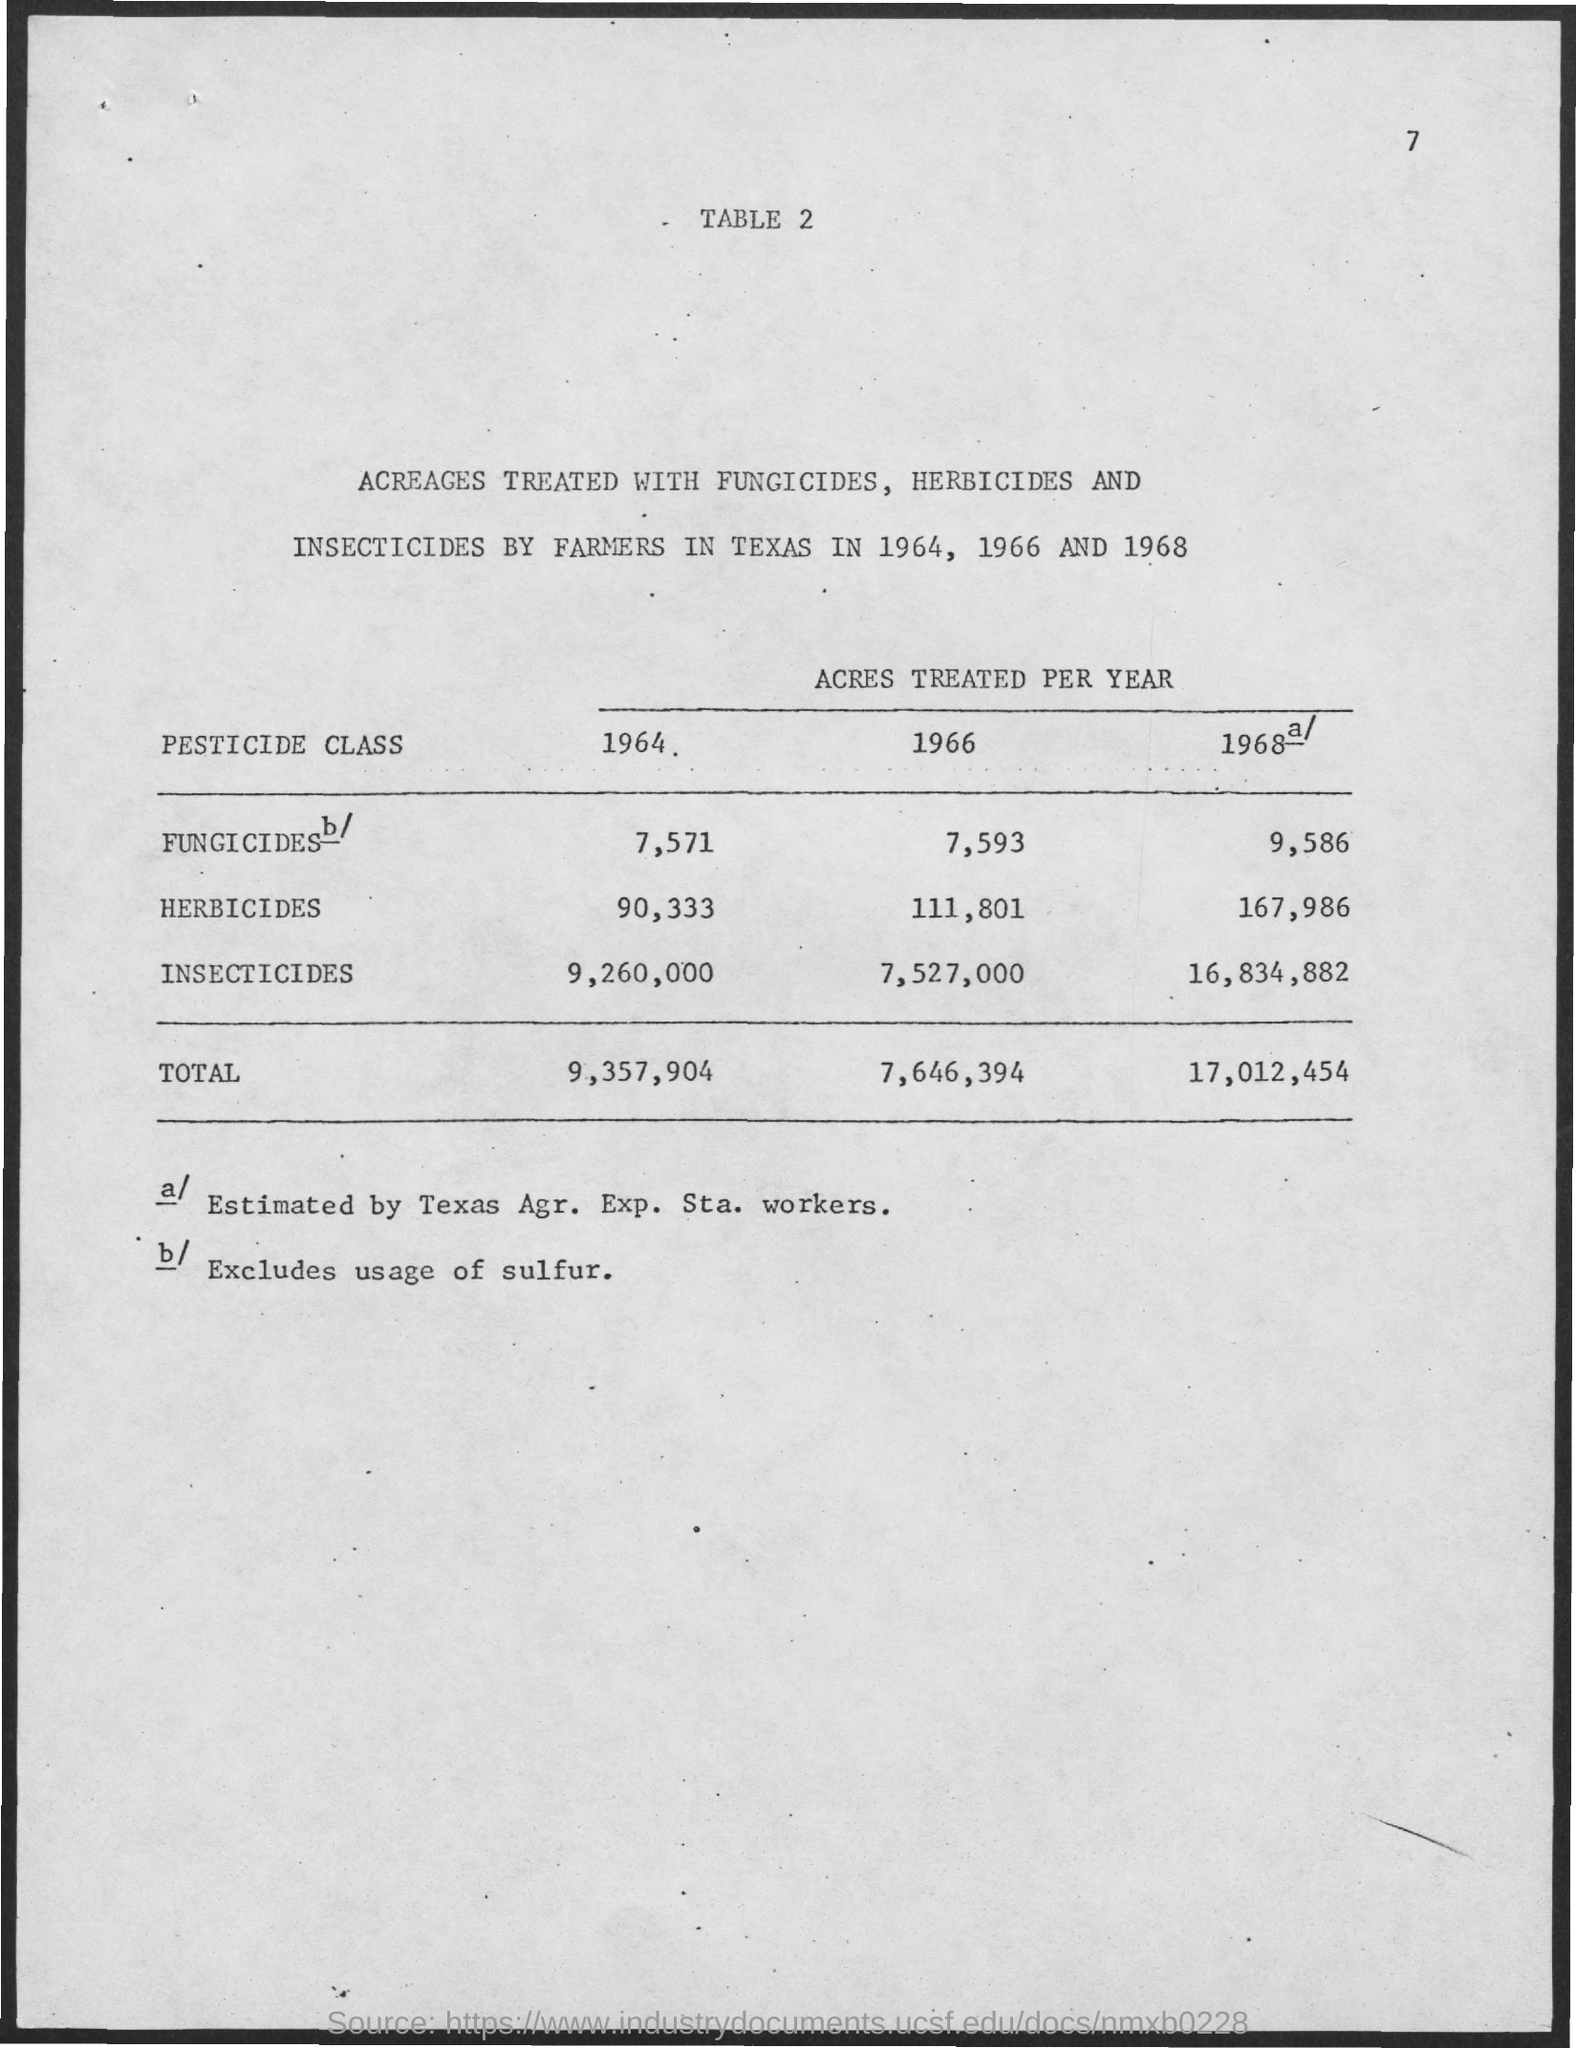How many acres treated with Herbicides in the year 1964?
Provide a short and direct response. 90,333. Total acres treated in the year 1966?
Provide a succinct answer. 7,646,394. In which year total acres treated with different pesticides is larger?
Give a very brief answer. 1968. 